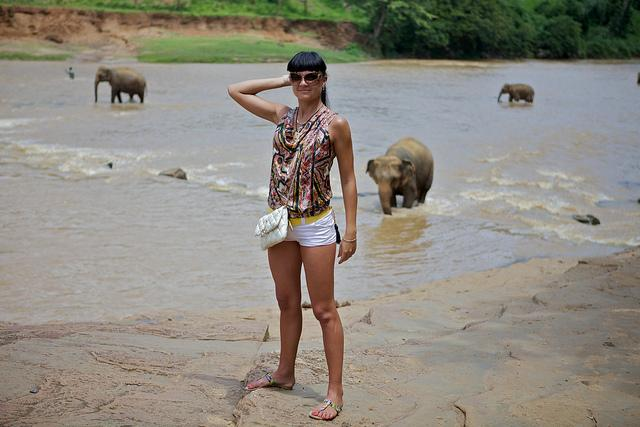Why is the woman holding her hand to her head? posing 